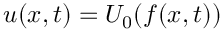<formula> <loc_0><loc_0><loc_500><loc_500>u ( x , t ) = U _ { 0 } ( f ( x , t ) )</formula> 